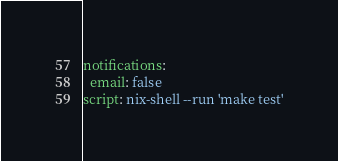<code> <loc_0><loc_0><loc_500><loc_500><_YAML_>notifications:
  email: false
script: nix-shell --run 'make test'
</code> 